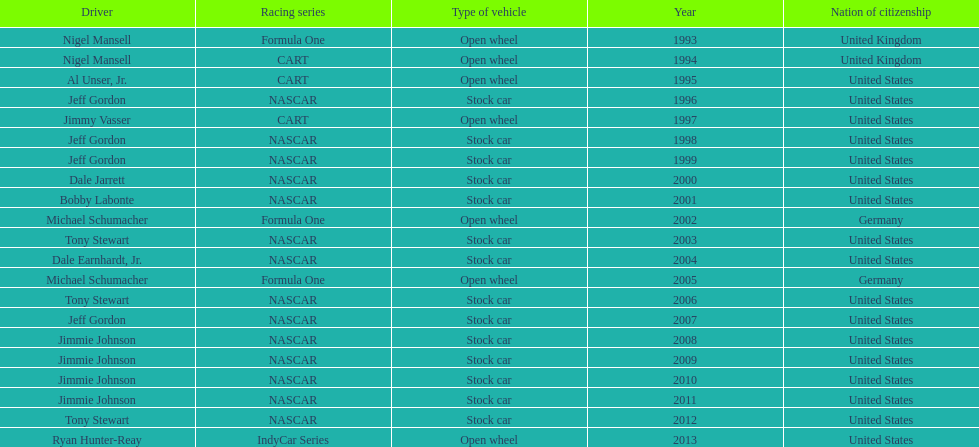Which driver managed to secure four wins in a row? Jimmie Johnson. 